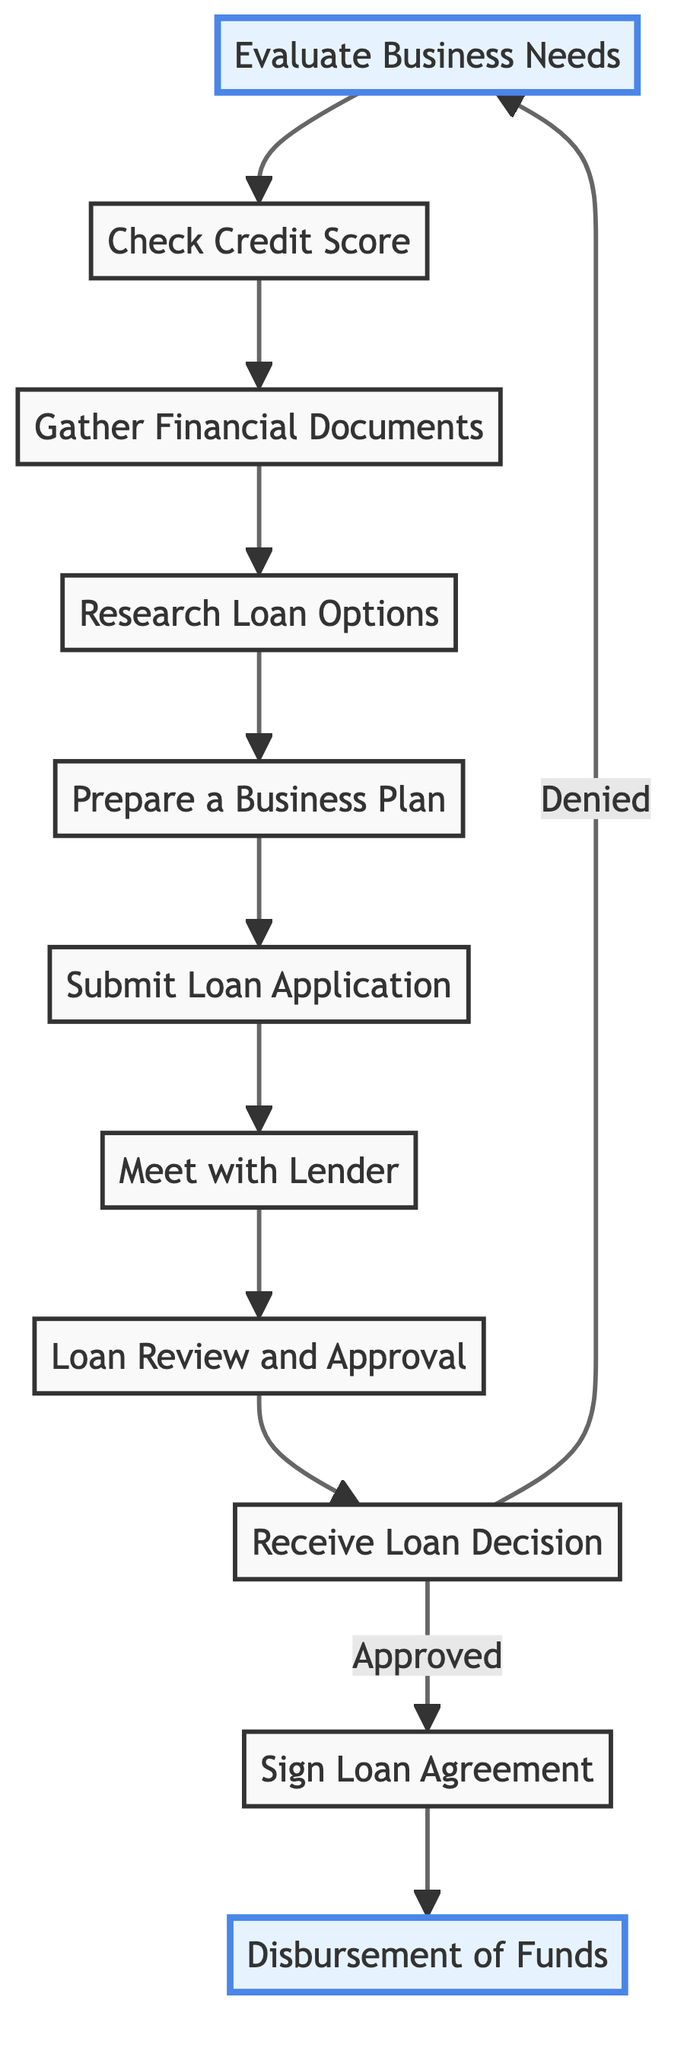What is the first step in the loan application process? The first step in the flow chart is "Evaluate Business Needs," indicating the initial action one should take when applying for a small business loan.
Answer: Evaluate Business Needs How many total steps are there in the diagram? The flow chart consists of eleven distinct steps labeled from one to eleven, capturing the full process of applying for a loan.
Answer: 11 What is the last step after receiving the loan decision if the loan is approved? Following the approval of the loan decision, the next step indicated in the flow chart is "Sign Loan Agreement."
Answer: Sign Loan Agreement What happens if the loan decision is denied? If the loan decision is denied, the flow chart shows that the process loops back to the first step, which is "Evaluate Business Needs," implying one may need to reassess.
Answer: Evaluate Business Needs Which step involves submitting the application form? The flow chart specifies that "Submit Loan Application" is the step where the applicant must fill out and submit the required loan application.
Answer: Submit Loan Application How many steps come before meeting with the lender? There are six steps leading up to "Meet with Lender," as it appears after "Submit Loan Application" in the sequence of actions.
Answer: 6 What type of documents must be gathered before researching loan options? The flow chart lists "Gather Financial Documents" as the step where various financial documents such as tax returns must be collected before moving on to researching loan options.
Answer: Gather Financial Documents What is the purpose of the "Prepare a Business Plan" step? The purpose of the "Prepare a Business Plan" step is to write a detailed plan that outlines critical aspects such as the business model and financial projections necessary for loan approval.
Answer: Write a detailed business plan What does "Loan Review and Approval" refer to in this flow? In the flow chart, "Loan Review and Approval" signifies the stage where the lender reviews the submitted application and completes any required due diligence before making a decision.
Answer: Review the application Which two steps are highlighted in the diagram? The flow chart highlights "Evaluate Business Needs" and "Disbursement of Funds," emphasizing their importance in the loan application process.
Answer: Evaluate Business Needs, Disbursement of Funds 